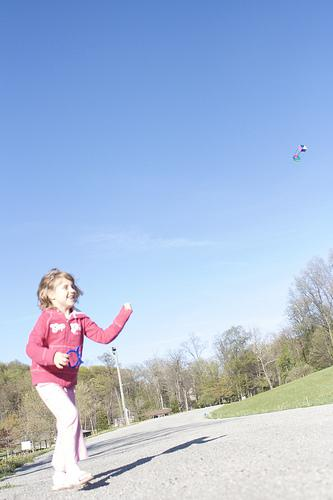Question: where was the picture taken?
Choices:
A. In a car.
B. On the street.
C. On a mountain.
D. On a boat.
Answer with the letter. Answer: B Question: what color is the girl's shirt?
Choices:
A. White.
B. Pink.
C. Red.
D. Black.
Answer with the letter. Answer: B Question: who is holding the kite string?
Choices:
A. The boy.
B. The woman.
C. The girl.
D. The man.
Answer with the letter. Answer: C Question: what is in the sky?
Choices:
A. A kite.
B. A balloon.
C. A bird.
D. A plane.
Answer with the letter. Answer: A 